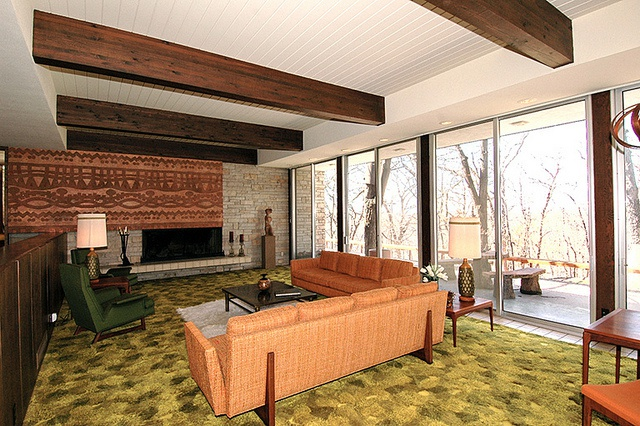Describe the objects in this image and their specific colors. I can see couch in lightgray, orange, brown, salmon, and red tones, chair in lightgray, black, darkgreen, and maroon tones, couch in lightgray, brown, maroon, and red tones, chair in lightgray, red, maroon, and salmon tones, and chair in lightgray, black, darkgreen, gray, and maroon tones in this image. 